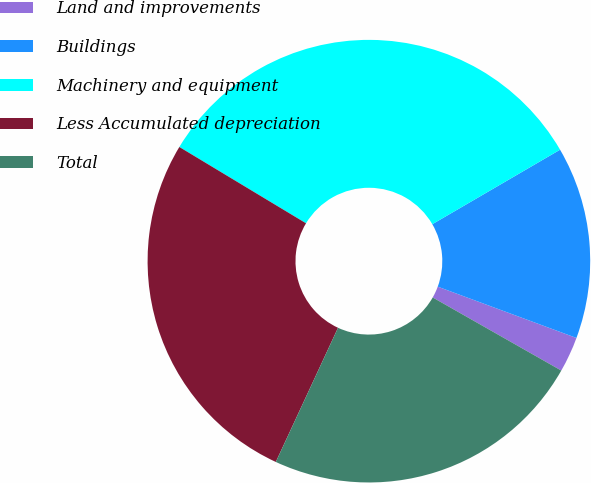<chart> <loc_0><loc_0><loc_500><loc_500><pie_chart><fcel>Land and improvements<fcel>Buildings<fcel>Machinery and equipment<fcel>Less Accumulated depreciation<fcel>Total<nl><fcel>2.59%<fcel>14.04%<fcel>32.97%<fcel>26.72%<fcel>23.68%<nl></chart> 